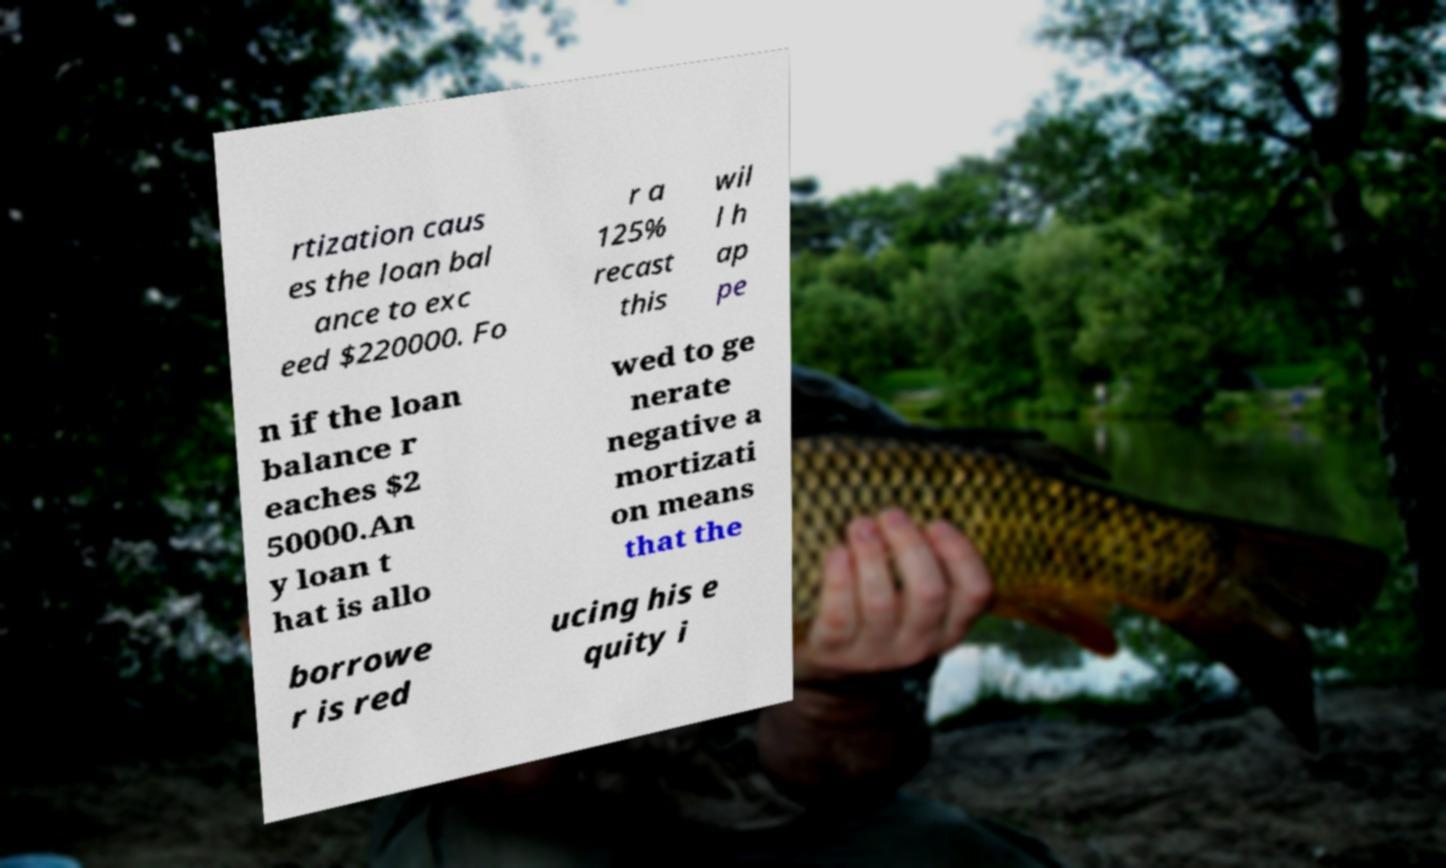What messages or text are displayed in this image? I need them in a readable, typed format. rtization caus es the loan bal ance to exc eed $220000. Fo r a 125% recast this wil l h ap pe n if the loan balance r eaches $2 50000.An y loan t hat is allo wed to ge nerate negative a mortizati on means that the borrowe r is red ucing his e quity i 